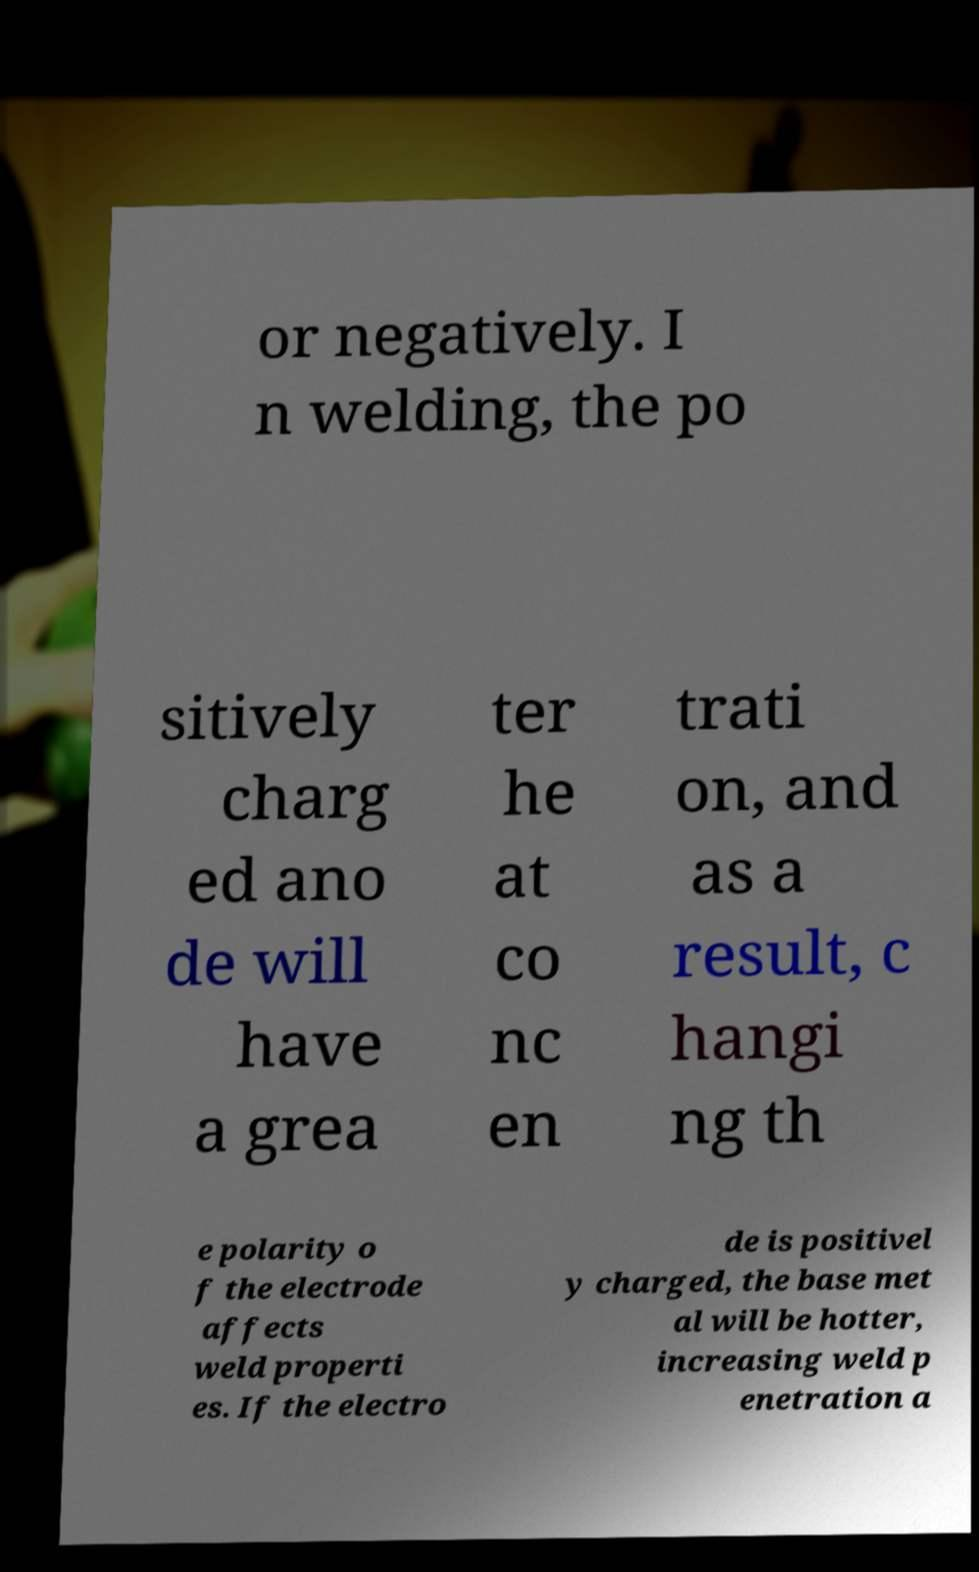Please identify and transcribe the text found in this image. or negatively. I n welding, the po sitively charg ed ano de will have a grea ter he at co nc en trati on, and as a result, c hangi ng th e polarity o f the electrode affects weld properti es. If the electro de is positivel y charged, the base met al will be hotter, increasing weld p enetration a 